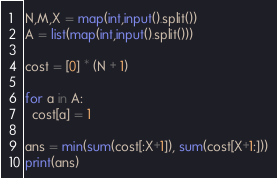Convert code to text. <code><loc_0><loc_0><loc_500><loc_500><_Python_>N,M,X = map(int,input().split())
A = list(map(int,input().split()))

cost = [0] * (N + 1)

for a in A:
  cost[a] = 1
  
ans = min(sum(cost[:X+1]), sum(cost[X+1:]))
print(ans)</code> 